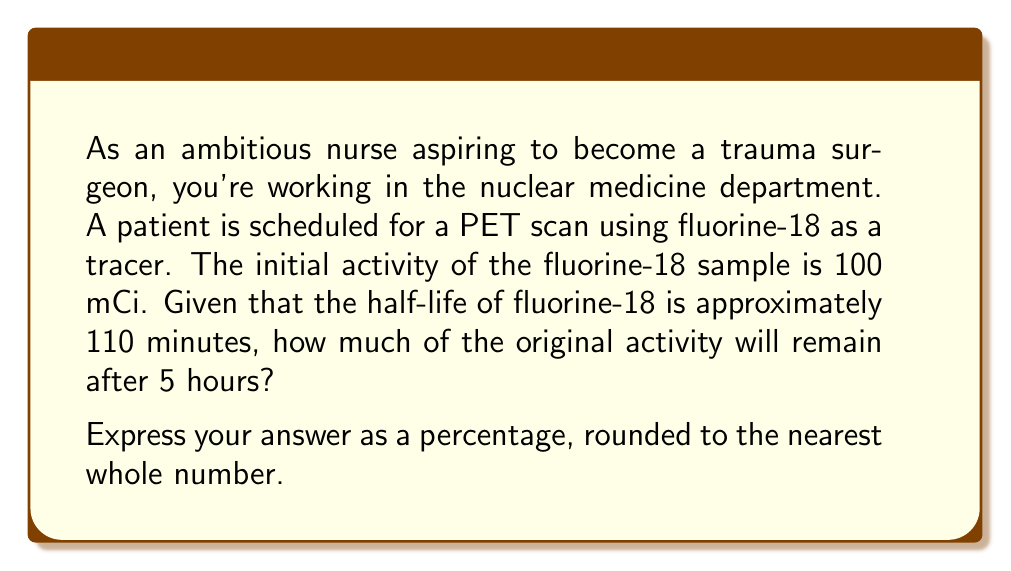Can you answer this question? To solve this problem, we'll use the exponential decay formula and the concept of half-life. Let's break it down step-by-step:

1) The exponential decay formula is:

   $$A(t) = A_0 \cdot (0.5)^{t/t_{1/2}}$$

   where:
   $A(t)$ is the amount remaining after time $t$
   $A_0$ is the initial amount
   $t$ is the time elapsed
   $t_{1/2}$ is the half-life

2) We're given:
   $A_0 = 100$ mCi
   $t_{1/2} = 110$ minutes
   $t = 5$ hours = 300 minutes

3) Let's substitute these values into the formula:

   $$A(300) = 100 \cdot (0.5)^{300/110}$$

4) Simplify the exponent:
   $$A(300) = 100 \cdot (0.5)^{2.727...}$$

5) Calculate using a scientific calculator:
   $$A(300) \approx 15.09 \text{ mCi}$$

6) To express this as a percentage of the original activity:
   $$\frac{15.09}{100} \times 100\% \approx 15.09\%$$

7) Rounding to the nearest whole number:
   15% of the original activity remains after 5 hours.
Answer: 15% 